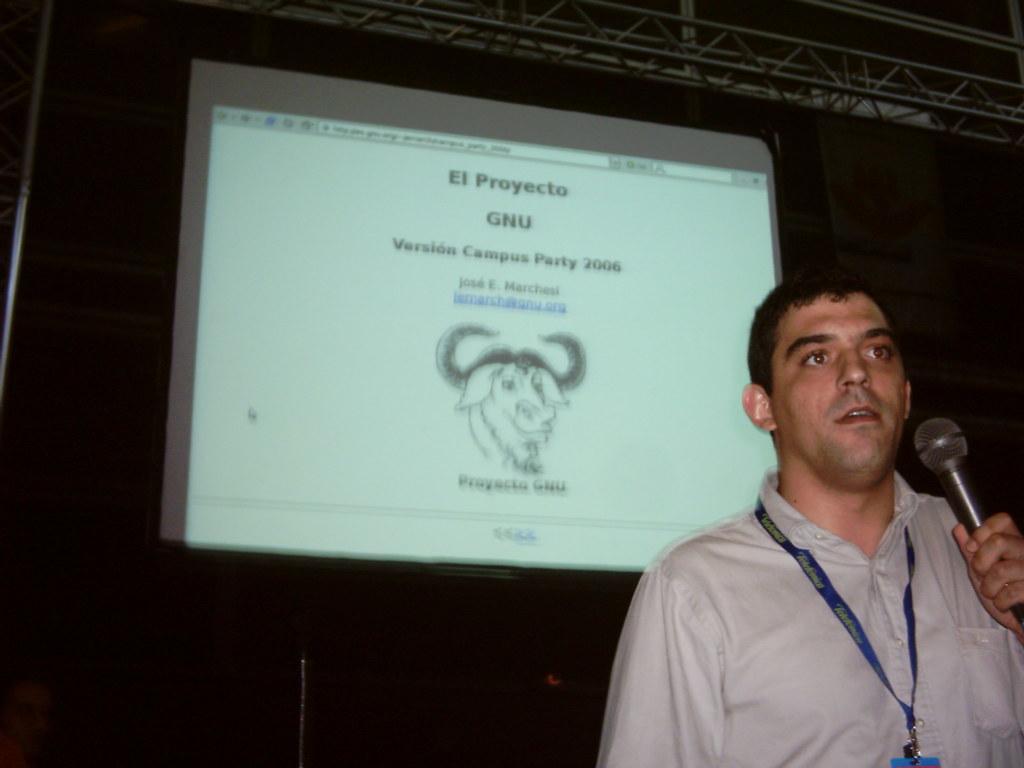Please provide a concise description of this image. a person at the right is holding a microphone in his hand. behind him there is a projector display. on the display version campus party 2006 is shown. 